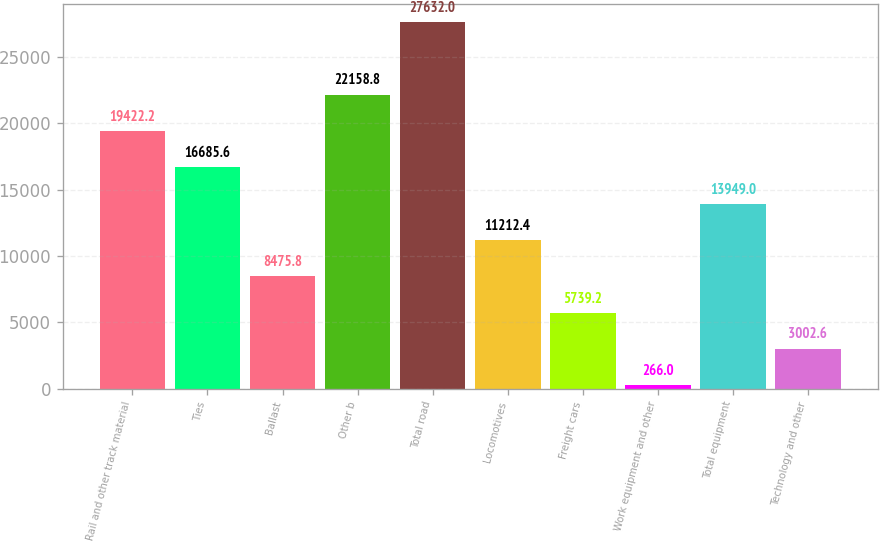Convert chart to OTSL. <chart><loc_0><loc_0><loc_500><loc_500><bar_chart><fcel>Rail and other track material<fcel>Ties<fcel>Ballast<fcel>Other b<fcel>Total road<fcel>Locomotives<fcel>Freight cars<fcel>Work equipment and other<fcel>Total equipment<fcel>Technology and other<nl><fcel>19422.2<fcel>16685.6<fcel>8475.8<fcel>22158.8<fcel>27632<fcel>11212.4<fcel>5739.2<fcel>266<fcel>13949<fcel>3002.6<nl></chart> 